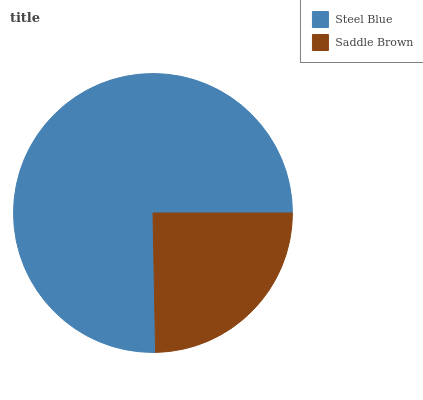Is Saddle Brown the minimum?
Answer yes or no. Yes. Is Steel Blue the maximum?
Answer yes or no. Yes. Is Saddle Brown the maximum?
Answer yes or no. No. Is Steel Blue greater than Saddle Brown?
Answer yes or no. Yes. Is Saddle Brown less than Steel Blue?
Answer yes or no. Yes. Is Saddle Brown greater than Steel Blue?
Answer yes or no. No. Is Steel Blue less than Saddle Brown?
Answer yes or no. No. Is Steel Blue the high median?
Answer yes or no. Yes. Is Saddle Brown the low median?
Answer yes or no. Yes. Is Saddle Brown the high median?
Answer yes or no. No. Is Steel Blue the low median?
Answer yes or no. No. 